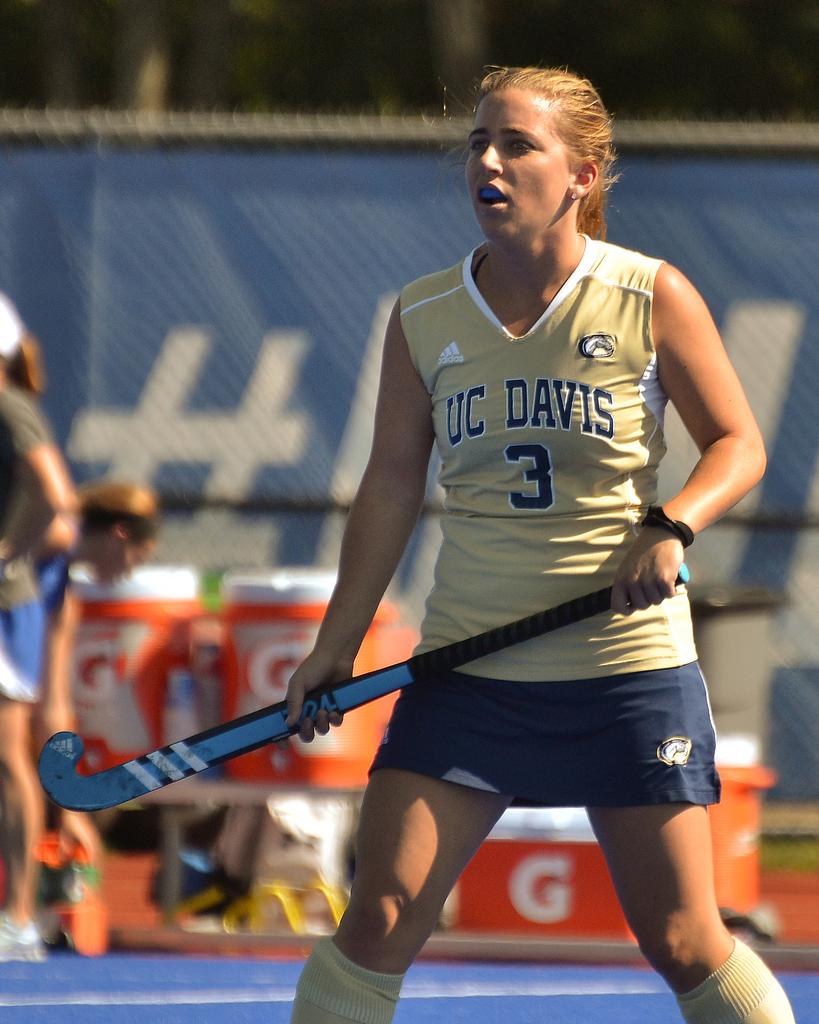What school does she play for?
Your answer should be compact. Uc davis. 